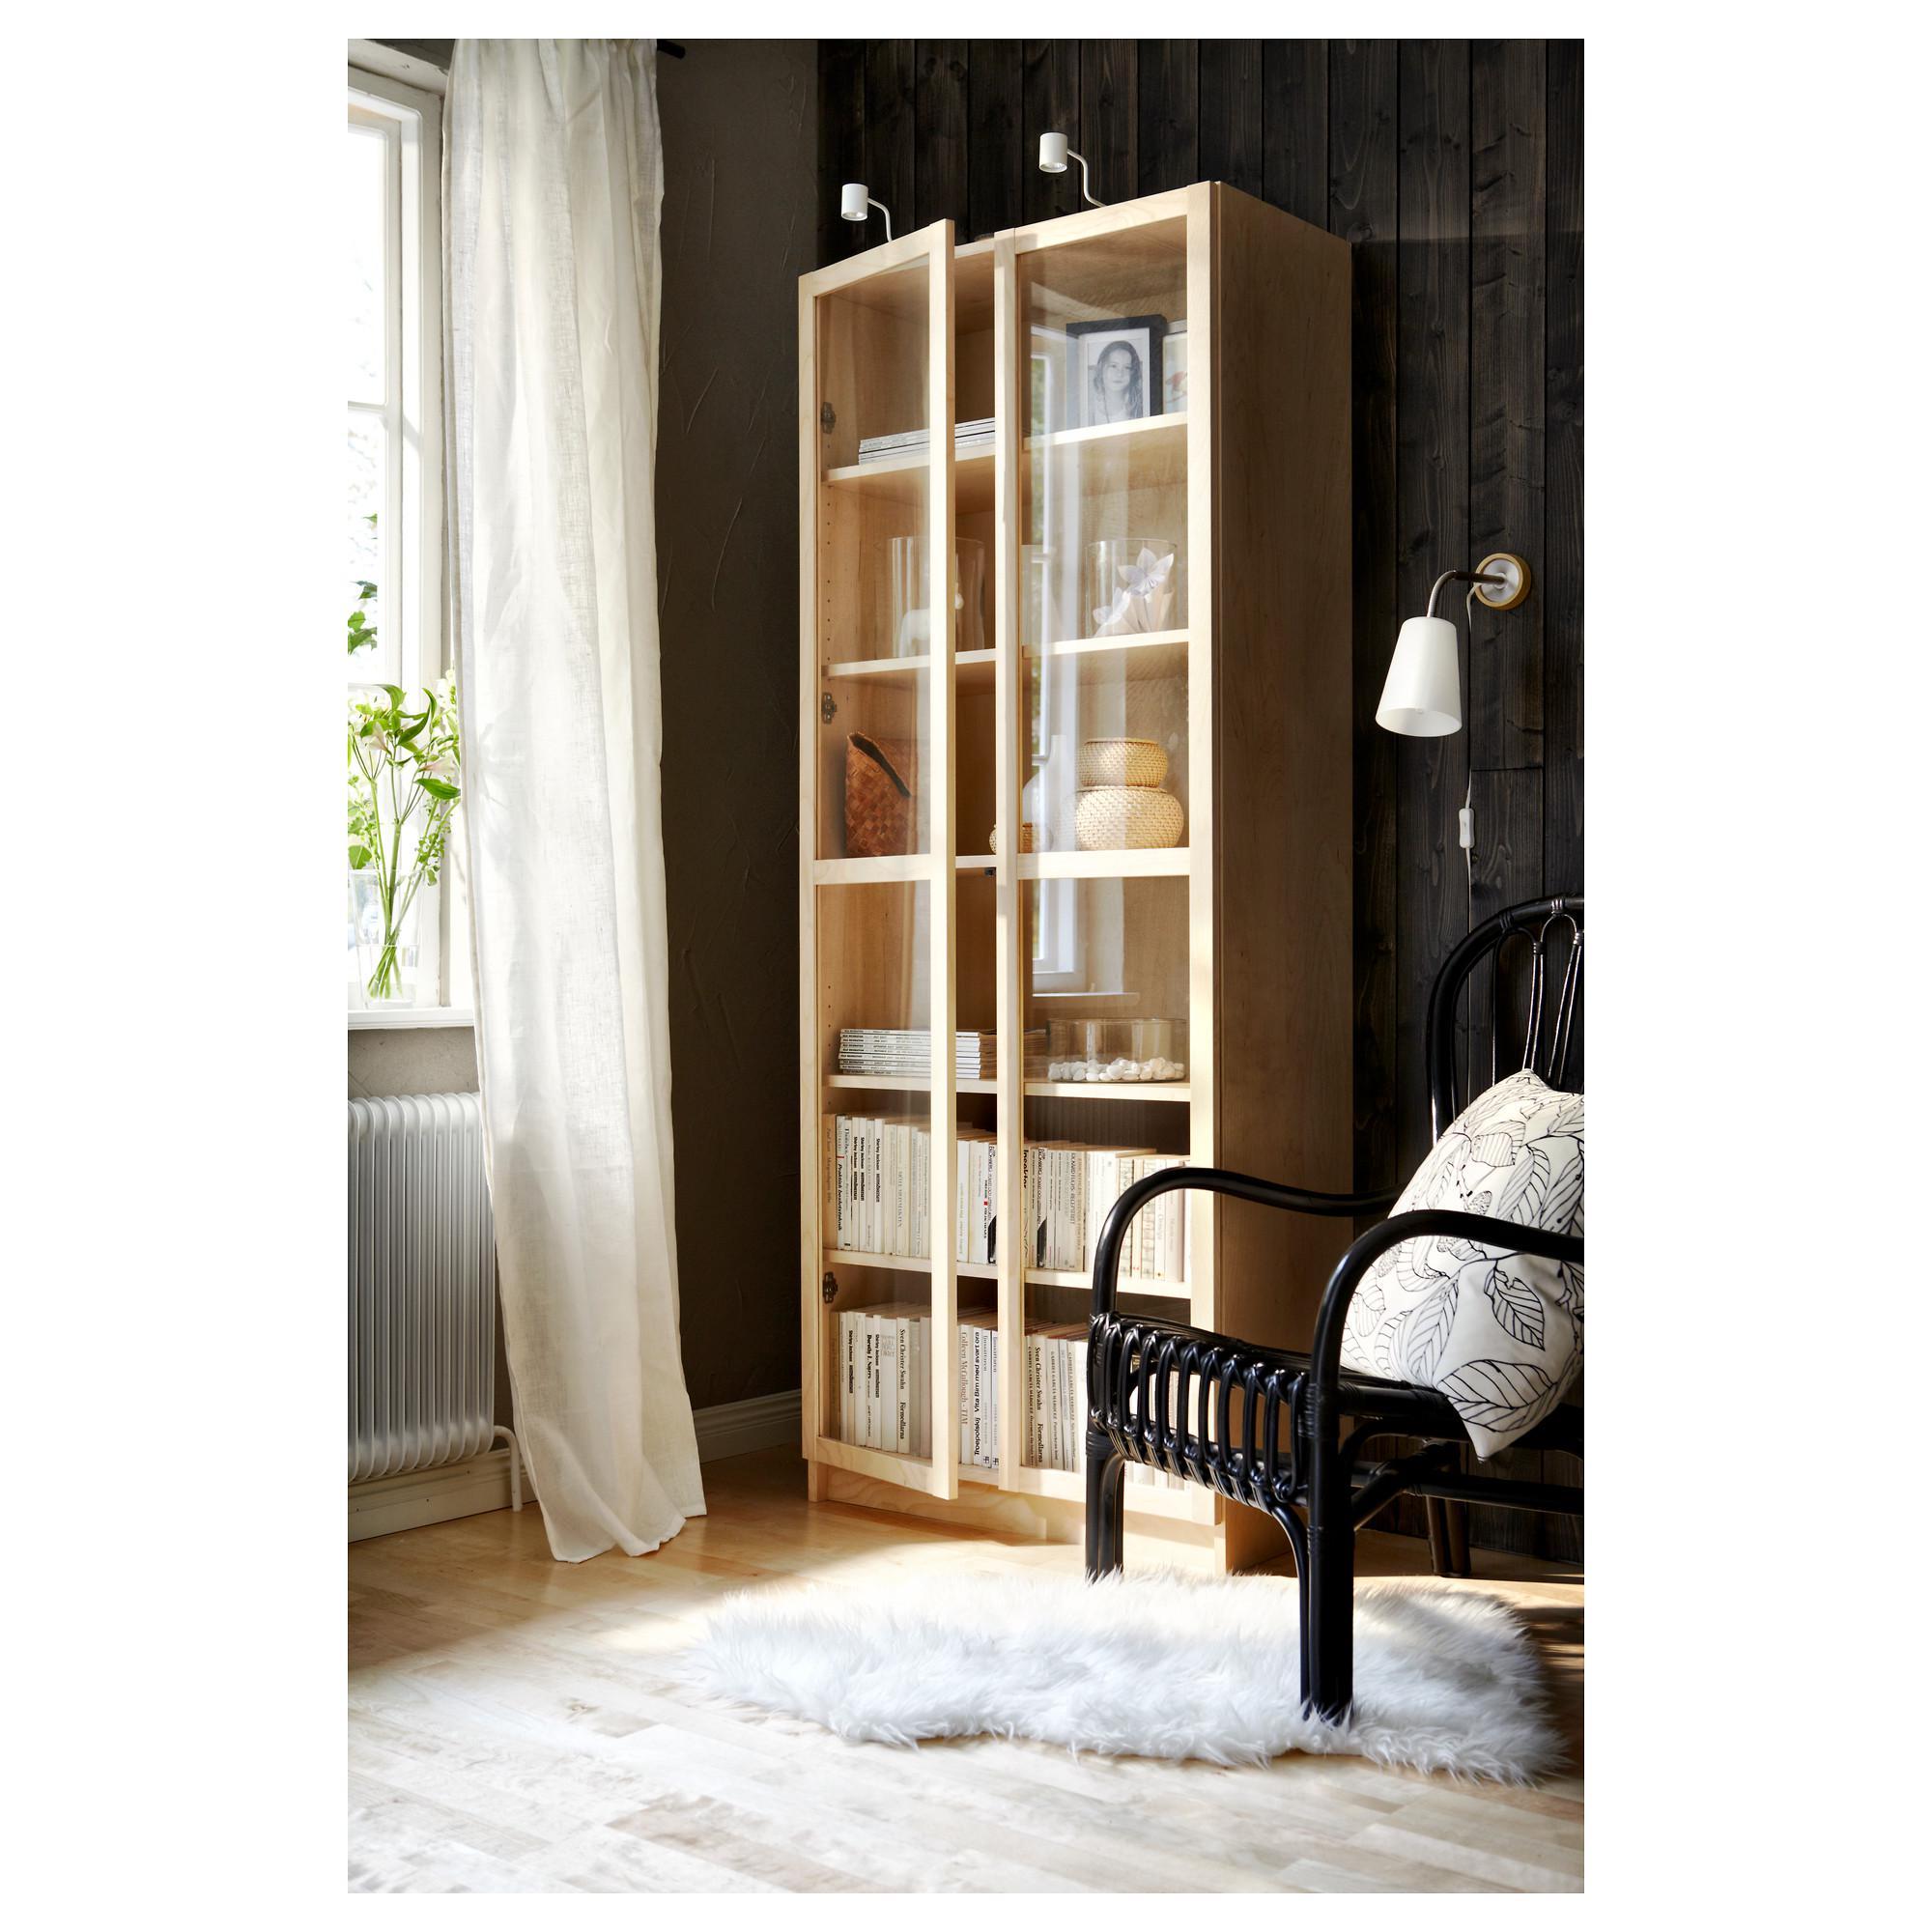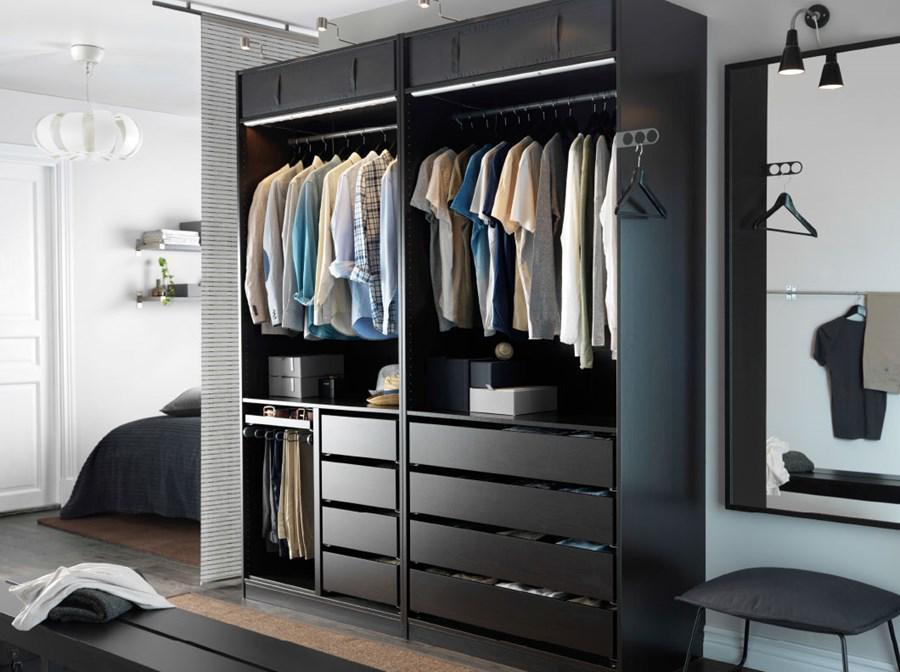The first image is the image on the left, the second image is the image on the right. For the images shown, is this caption "A single white lamp hangs down from the ceiling in one of the images." true? Answer yes or no. Yes. The first image is the image on the left, the second image is the image on the right. Examine the images to the left and right. Is the description "One image shows a green plant in a white vase standing on the floor to the left of an upright set of shelves with closed, glass-front double doors." accurate? Answer yes or no. No. 